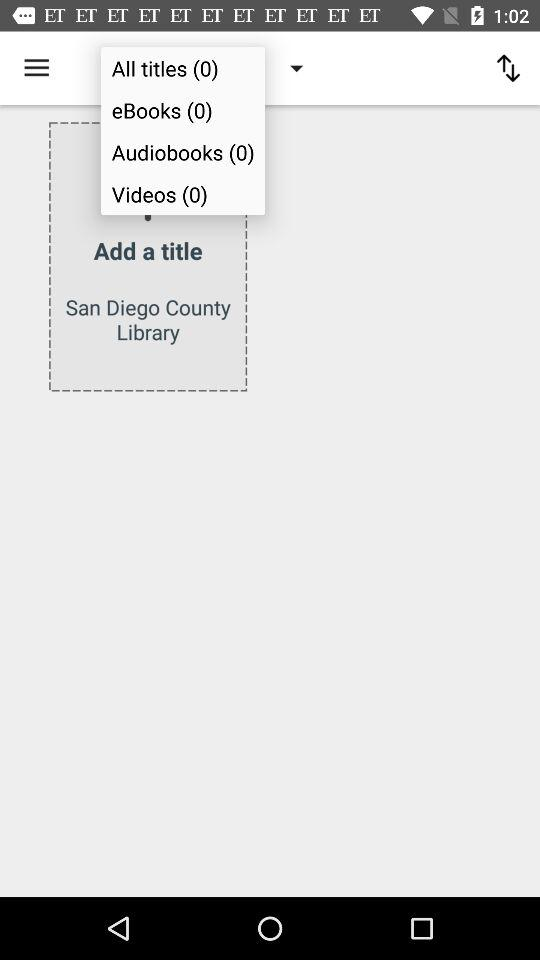How can we get a library card for the San Diego County Library?
When the provided information is insufficient, respond with <no answer>. <no answer> 